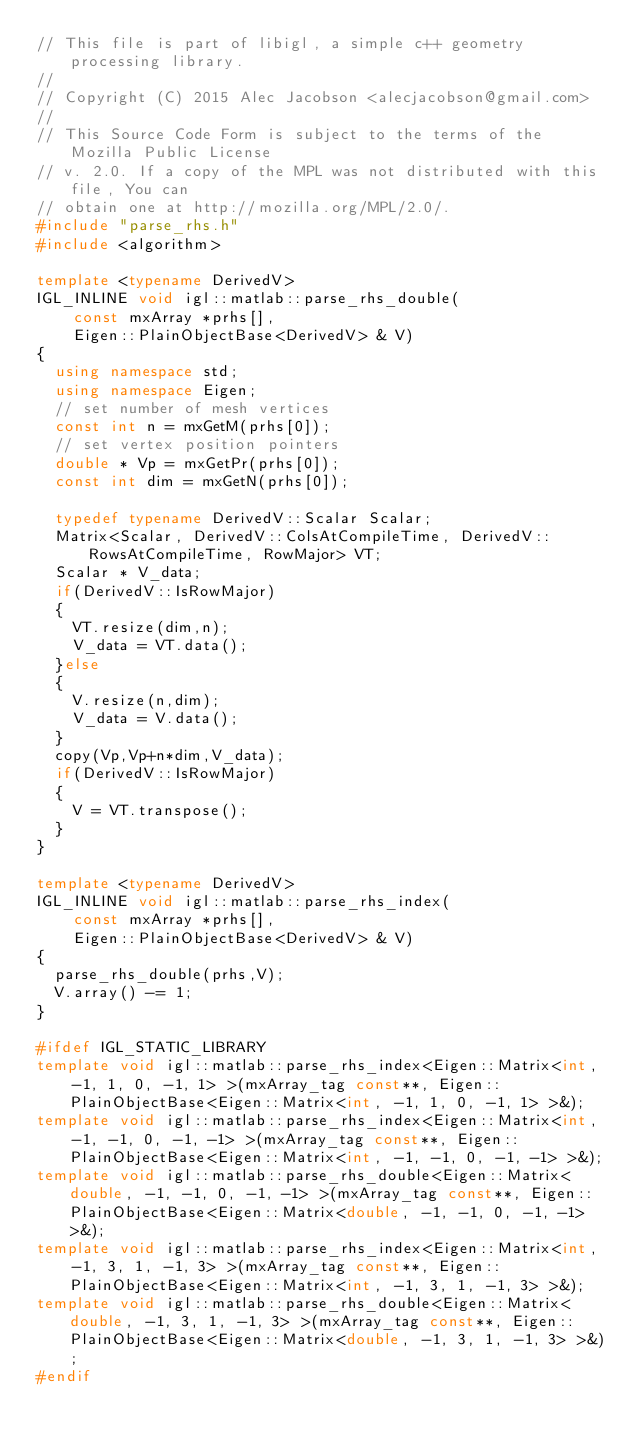<code> <loc_0><loc_0><loc_500><loc_500><_C++_>// This file is part of libigl, a simple c++ geometry processing library.
// 
// Copyright (C) 2015 Alec Jacobson <alecjacobson@gmail.com>
// 
// This Source Code Form is subject to the terms of the Mozilla Public License 
// v. 2.0. If a copy of the MPL was not distributed with this file, You can 
// obtain one at http://mozilla.org/MPL/2.0/.
#include "parse_rhs.h"
#include <algorithm>

template <typename DerivedV>
IGL_INLINE void igl::matlab::parse_rhs_double(
    const mxArray *prhs[], 
    Eigen::PlainObjectBase<DerivedV> & V)
{
  using namespace std;
  using namespace Eigen;
  // set number of mesh vertices
  const int n = mxGetM(prhs[0]);
  // set vertex position pointers
  double * Vp = mxGetPr(prhs[0]);
  const int dim = mxGetN(prhs[0]);

  typedef typename DerivedV::Scalar Scalar;
  Matrix<Scalar, DerivedV::ColsAtCompileTime, DerivedV::RowsAtCompileTime, RowMajor> VT;
  Scalar * V_data;
  if(DerivedV::IsRowMajor)
  {
    VT.resize(dim,n);
    V_data = VT.data();
  }else
  {
    V.resize(n,dim);
    V_data = V.data();
  }
  copy(Vp,Vp+n*dim,V_data);
  if(DerivedV::IsRowMajor)
  {
    V = VT.transpose();
  }
}

template <typename DerivedV>
IGL_INLINE void igl::matlab::parse_rhs_index(
    const mxArray *prhs[], 
    Eigen::PlainObjectBase<DerivedV> & V)
{
  parse_rhs_double(prhs,V);
  V.array() -= 1;
}

#ifdef IGL_STATIC_LIBRARY
template void igl::matlab::parse_rhs_index<Eigen::Matrix<int, -1, 1, 0, -1, 1> >(mxArray_tag const**, Eigen::PlainObjectBase<Eigen::Matrix<int, -1, 1, 0, -1, 1> >&);
template void igl::matlab::parse_rhs_index<Eigen::Matrix<int, -1, -1, 0, -1, -1> >(mxArray_tag const**, Eigen::PlainObjectBase<Eigen::Matrix<int, -1, -1, 0, -1, -1> >&);
template void igl::matlab::parse_rhs_double<Eigen::Matrix<double, -1, -1, 0, -1, -1> >(mxArray_tag const**, Eigen::PlainObjectBase<Eigen::Matrix<double, -1, -1, 0, -1, -1> >&);
template void igl::matlab::parse_rhs_index<Eigen::Matrix<int, -1, 3, 1, -1, 3> >(mxArray_tag const**, Eigen::PlainObjectBase<Eigen::Matrix<int, -1, 3, 1, -1, 3> >&);
template void igl::matlab::parse_rhs_double<Eigen::Matrix<double, -1, 3, 1, -1, 3> >(mxArray_tag const**, Eigen::PlainObjectBase<Eigen::Matrix<double, -1, 3, 1, -1, 3> >&);
#endif
</code> 